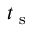<formula> <loc_0><loc_0><loc_500><loc_500>t _ { s }</formula> 